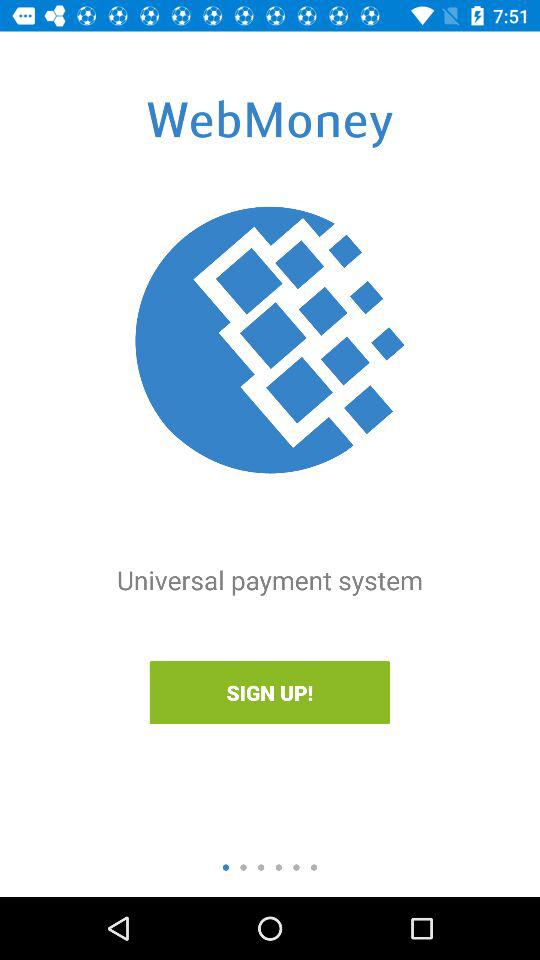What information is required for signing up?
When the provided information is insufficient, respond with <no answer>. <no answer> 